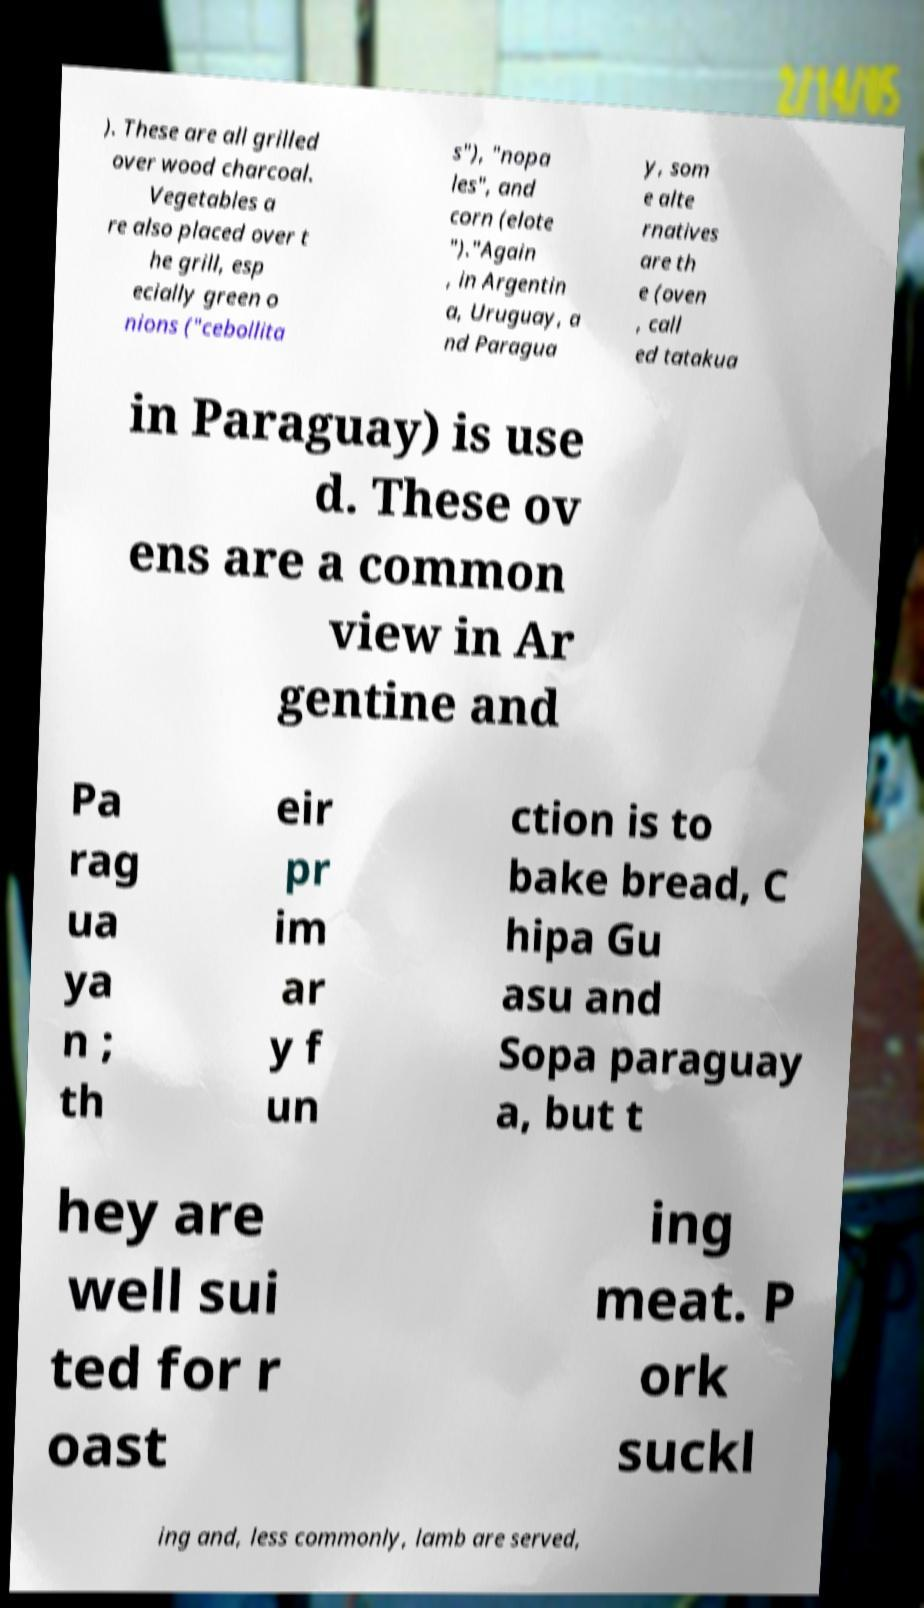Please read and relay the text visible in this image. What does it say? ). These are all grilled over wood charcoal. Vegetables a re also placed over t he grill, esp ecially green o nions ("cebollita s"), "nopa les", and corn (elote ")."Again , in Argentin a, Uruguay, a nd Paragua y, som e alte rnatives are th e (oven , call ed tatakua in Paraguay) is use d. These ov ens are a common view in Ar gentine and Pa rag ua ya n ; th eir pr im ar y f un ction is to bake bread, C hipa Gu asu and Sopa paraguay a, but t hey are well sui ted for r oast ing meat. P ork suckl ing and, less commonly, lamb are served, 